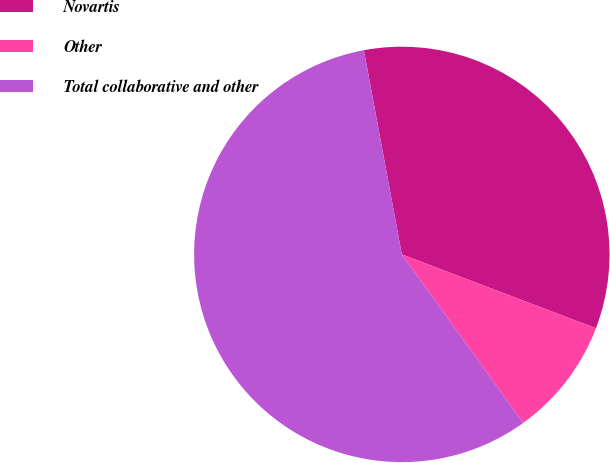Convert chart. <chart><loc_0><loc_0><loc_500><loc_500><pie_chart><fcel>Novartis<fcel>Other<fcel>Total collaborative and other<nl><fcel>33.71%<fcel>9.28%<fcel>57.01%<nl></chart> 